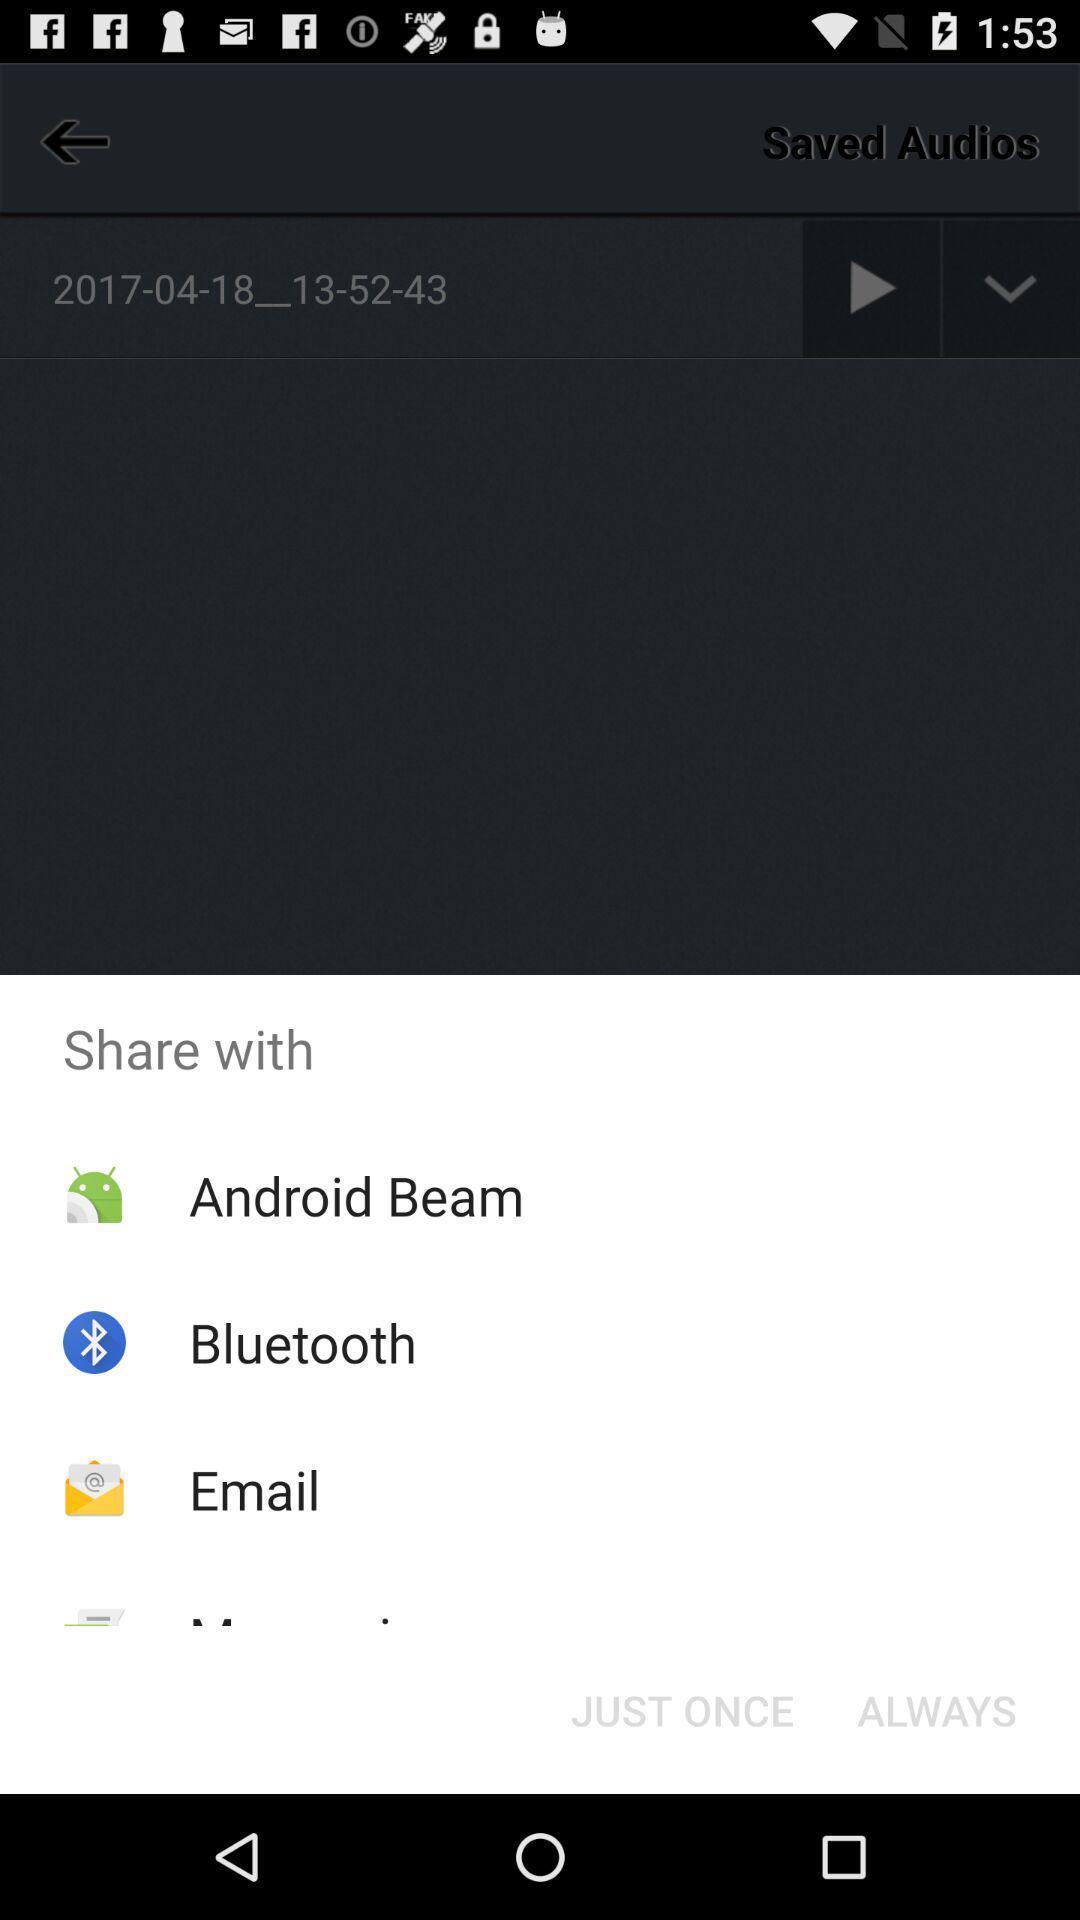What can you discern from this picture? Pop-up showing various audio sharing options. 